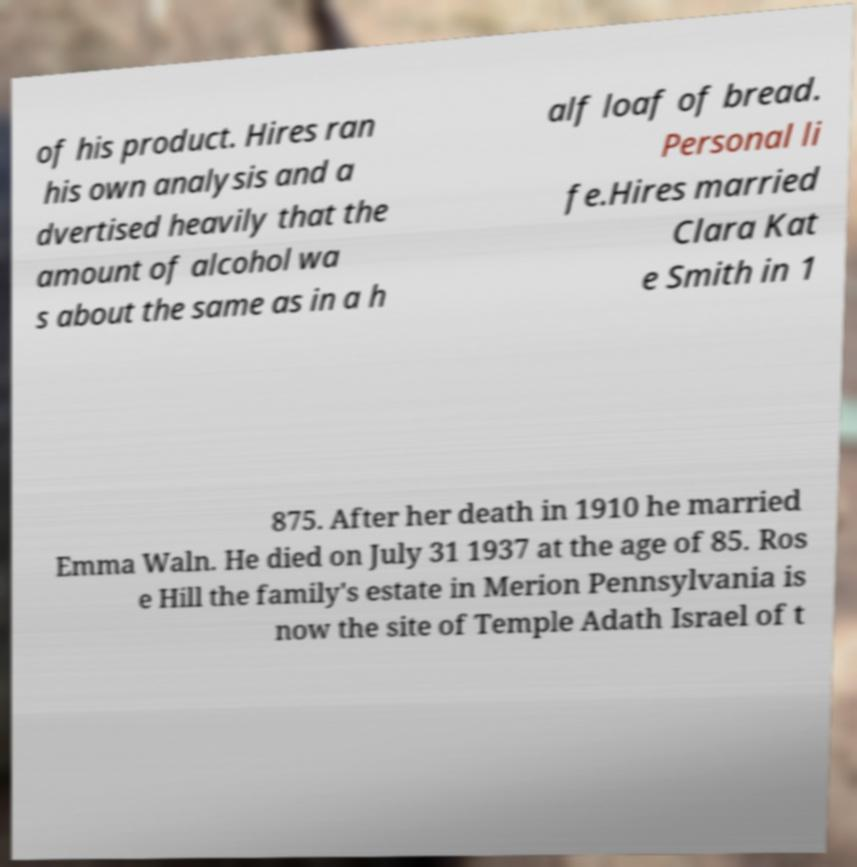Please read and relay the text visible in this image. What does it say? of his product. Hires ran his own analysis and a dvertised heavily that the amount of alcohol wa s about the same as in a h alf loaf of bread. Personal li fe.Hires married Clara Kat e Smith in 1 875. After her death in 1910 he married Emma Waln. He died on July 31 1937 at the age of 85. Ros e Hill the family's estate in Merion Pennsylvania is now the site of Temple Adath Israel of t 